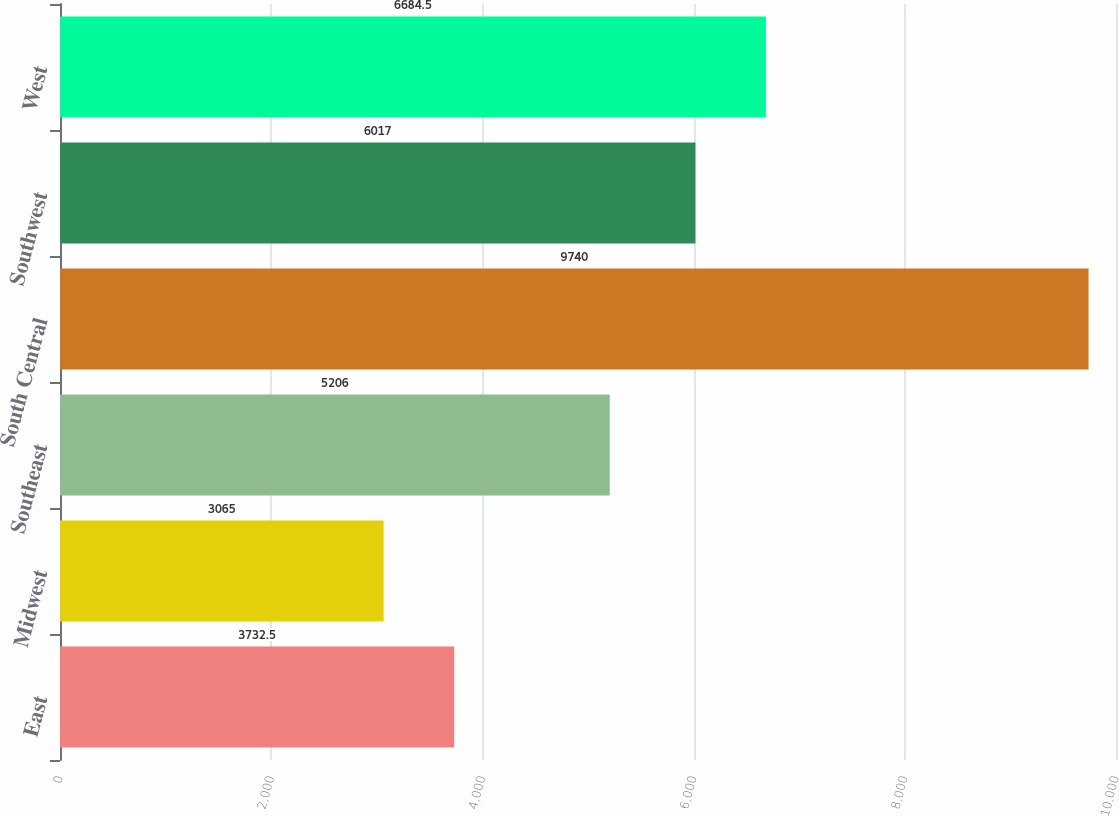Convert chart to OTSL. <chart><loc_0><loc_0><loc_500><loc_500><bar_chart><fcel>East<fcel>Midwest<fcel>Southeast<fcel>South Central<fcel>Southwest<fcel>West<nl><fcel>3732.5<fcel>3065<fcel>5206<fcel>9740<fcel>6017<fcel>6684.5<nl></chart> 